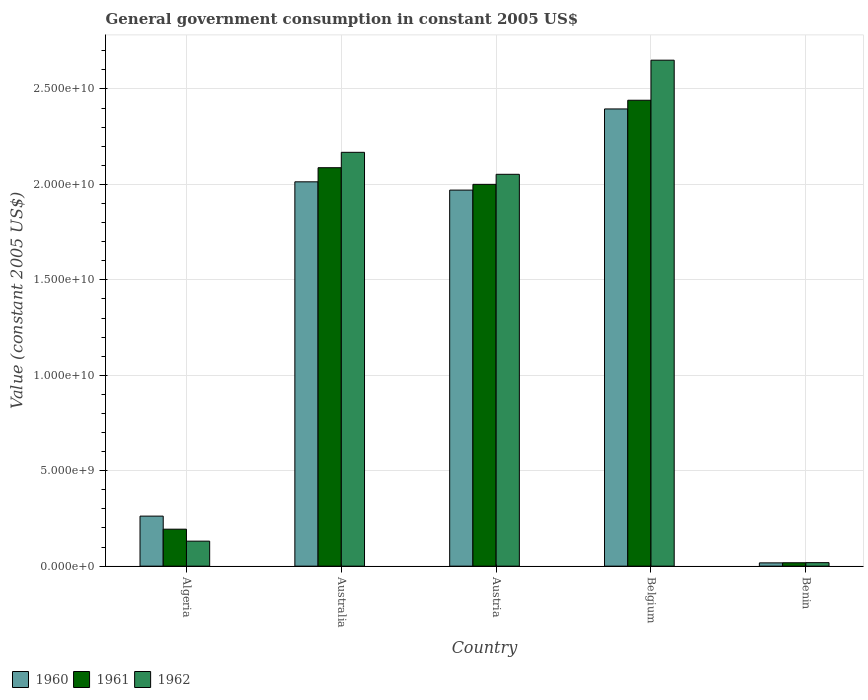How many bars are there on the 1st tick from the left?
Provide a succinct answer. 3. How many bars are there on the 2nd tick from the right?
Ensure brevity in your answer.  3. What is the label of the 5th group of bars from the left?
Give a very brief answer. Benin. In how many cases, is the number of bars for a given country not equal to the number of legend labels?
Your answer should be very brief. 0. What is the government conusmption in 1960 in Benin?
Offer a very short reply. 1.73e+08. Across all countries, what is the maximum government conusmption in 1962?
Keep it short and to the point. 2.65e+1. Across all countries, what is the minimum government conusmption in 1960?
Provide a short and direct response. 1.73e+08. In which country was the government conusmption in 1962 maximum?
Give a very brief answer. Belgium. In which country was the government conusmption in 1961 minimum?
Ensure brevity in your answer.  Benin. What is the total government conusmption in 1962 in the graph?
Ensure brevity in your answer.  7.02e+1. What is the difference between the government conusmption in 1961 in Algeria and that in Benin?
Provide a succinct answer. 1.76e+09. What is the difference between the government conusmption in 1962 in Belgium and the government conusmption in 1960 in Austria?
Make the answer very short. 6.81e+09. What is the average government conusmption in 1960 per country?
Provide a succinct answer. 1.33e+1. What is the difference between the government conusmption of/in 1961 and government conusmption of/in 1962 in Austria?
Your answer should be very brief. -5.26e+08. What is the ratio of the government conusmption in 1962 in Australia to that in Austria?
Make the answer very short. 1.06. What is the difference between the highest and the second highest government conusmption in 1961?
Keep it short and to the point. -8.72e+08. What is the difference between the highest and the lowest government conusmption in 1961?
Give a very brief answer. 2.42e+1. Are all the bars in the graph horizontal?
Give a very brief answer. No. How are the legend labels stacked?
Offer a very short reply. Horizontal. What is the title of the graph?
Offer a terse response. General government consumption in constant 2005 US$. What is the label or title of the X-axis?
Your response must be concise. Country. What is the label or title of the Y-axis?
Your answer should be very brief. Value (constant 2005 US$). What is the Value (constant 2005 US$) in 1960 in Algeria?
Your response must be concise. 2.62e+09. What is the Value (constant 2005 US$) in 1961 in Algeria?
Give a very brief answer. 1.94e+09. What is the Value (constant 2005 US$) in 1962 in Algeria?
Your answer should be very brief. 1.31e+09. What is the Value (constant 2005 US$) of 1960 in Australia?
Provide a short and direct response. 2.01e+1. What is the Value (constant 2005 US$) of 1961 in Australia?
Keep it short and to the point. 2.09e+1. What is the Value (constant 2005 US$) in 1962 in Australia?
Make the answer very short. 2.17e+1. What is the Value (constant 2005 US$) of 1960 in Austria?
Ensure brevity in your answer.  1.97e+1. What is the Value (constant 2005 US$) in 1961 in Austria?
Keep it short and to the point. 2.00e+1. What is the Value (constant 2005 US$) in 1962 in Austria?
Keep it short and to the point. 2.05e+1. What is the Value (constant 2005 US$) in 1960 in Belgium?
Give a very brief answer. 2.40e+1. What is the Value (constant 2005 US$) of 1961 in Belgium?
Keep it short and to the point. 2.44e+1. What is the Value (constant 2005 US$) of 1962 in Belgium?
Offer a terse response. 2.65e+1. What is the Value (constant 2005 US$) of 1960 in Benin?
Ensure brevity in your answer.  1.73e+08. What is the Value (constant 2005 US$) of 1961 in Benin?
Your answer should be very brief. 1.79e+08. What is the Value (constant 2005 US$) of 1962 in Benin?
Your answer should be compact. 1.85e+08. Across all countries, what is the maximum Value (constant 2005 US$) in 1960?
Your answer should be very brief. 2.40e+1. Across all countries, what is the maximum Value (constant 2005 US$) of 1961?
Your answer should be very brief. 2.44e+1. Across all countries, what is the maximum Value (constant 2005 US$) of 1962?
Offer a very short reply. 2.65e+1. Across all countries, what is the minimum Value (constant 2005 US$) in 1960?
Provide a succinct answer. 1.73e+08. Across all countries, what is the minimum Value (constant 2005 US$) of 1961?
Offer a terse response. 1.79e+08. Across all countries, what is the minimum Value (constant 2005 US$) in 1962?
Your answer should be very brief. 1.85e+08. What is the total Value (constant 2005 US$) of 1960 in the graph?
Your response must be concise. 6.66e+1. What is the total Value (constant 2005 US$) of 1961 in the graph?
Your answer should be compact. 6.74e+1. What is the total Value (constant 2005 US$) of 1962 in the graph?
Offer a very short reply. 7.02e+1. What is the difference between the Value (constant 2005 US$) of 1960 in Algeria and that in Australia?
Provide a short and direct response. -1.75e+1. What is the difference between the Value (constant 2005 US$) in 1961 in Algeria and that in Australia?
Ensure brevity in your answer.  -1.89e+1. What is the difference between the Value (constant 2005 US$) of 1962 in Algeria and that in Australia?
Keep it short and to the point. -2.04e+1. What is the difference between the Value (constant 2005 US$) of 1960 in Algeria and that in Austria?
Offer a terse response. -1.71e+1. What is the difference between the Value (constant 2005 US$) of 1961 in Algeria and that in Austria?
Offer a very short reply. -1.81e+1. What is the difference between the Value (constant 2005 US$) of 1962 in Algeria and that in Austria?
Your response must be concise. -1.92e+1. What is the difference between the Value (constant 2005 US$) in 1960 in Algeria and that in Belgium?
Keep it short and to the point. -2.13e+1. What is the difference between the Value (constant 2005 US$) of 1961 in Algeria and that in Belgium?
Ensure brevity in your answer.  -2.25e+1. What is the difference between the Value (constant 2005 US$) in 1962 in Algeria and that in Belgium?
Provide a succinct answer. -2.52e+1. What is the difference between the Value (constant 2005 US$) in 1960 in Algeria and that in Benin?
Give a very brief answer. 2.45e+09. What is the difference between the Value (constant 2005 US$) of 1961 in Algeria and that in Benin?
Offer a very short reply. 1.76e+09. What is the difference between the Value (constant 2005 US$) of 1962 in Algeria and that in Benin?
Make the answer very short. 1.13e+09. What is the difference between the Value (constant 2005 US$) of 1960 in Australia and that in Austria?
Provide a short and direct response. 4.34e+08. What is the difference between the Value (constant 2005 US$) of 1961 in Australia and that in Austria?
Ensure brevity in your answer.  8.72e+08. What is the difference between the Value (constant 2005 US$) of 1962 in Australia and that in Austria?
Your answer should be compact. 1.15e+09. What is the difference between the Value (constant 2005 US$) of 1960 in Australia and that in Belgium?
Ensure brevity in your answer.  -3.82e+09. What is the difference between the Value (constant 2005 US$) of 1961 in Australia and that in Belgium?
Offer a terse response. -3.53e+09. What is the difference between the Value (constant 2005 US$) of 1962 in Australia and that in Belgium?
Offer a terse response. -4.83e+09. What is the difference between the Value (constant 2005 US$) of 1960 in Australia and that in Benin?
Provide a short and direct response. 2.00e+1. What is the difference between the Value (constant 2005 US$) of 1961 in Australia and that in Benin?
Keep it short and to the point. 2.07e+1. What is the difference between the Value (constant 2005 US$) of 1962 in Australia and that in Benin?
Offer a terse response. 2.15e+1. What is the difference between the Value (constant 2005 US$) of 1960 in Austria and that in Belgium?
Provide a succinct answer. -4.25e+09. What is the difference between the Value (constant 2005 US$) in 1961 in Austria and that in Belgium?
Offer a terse response. -4.41e+09. What is the difference between the Value (constant 2005 US$) of 1962 in Austria and that in Belgium?
Provide a short and direct response. -5.98e+09. What is the difference between the Value (constant 2005 US$) of 1960 in Austria and that in Benin?
Provide a short and direct response. 1.95e+1. What is the difference between the Value (constant 2005 US$) of 1961 in Austria and that in Benin?
Provide a succinct answer. 1.98e+1. What is the difference between the Value (constant 2005 US$) of 1962 in Austria and that in Benin?
Your answer should be very brief. 2.03e+1. What is the difference between the Value (constant 2005 US$) of 1960 in Belgium and that in Benin?
Provide a succinct answer. 2.38e+1. What is the difference between the Value (constant 2005 US$) of 1961 in Belgium and that in Benin?
Your answer should be very brief. 2.42e+1. What is the difference between the Value (constant 2005 US$) in 1962 in Belgium and that in Benin?
Ensure brevity in your answer.  2.63e+1. What is the difference between the Value (constant 2005 US$) of 1960 in Algeria and the Value (constant 2005 US$) of 1961 in Australia?
Keep it short and to the point. -1.83e+1. What is the difference between the Value (constant 2005 US$) in 1960 in Algeria and the Value (constant 2005 US$) in 1962 in Australia?
Your answer should be very brief. -1.91e+1. What is the difference between the Value (constant 2005 US$) of 1961 in Algeria and the Value (constant 2005 US$) of 1962 in Australia?
Keep it short and to the point. -1.97e+1. What is the difference between the Value (constant 2005 US$) of 1960 in Algeria and the Value (constant 2005 US$) of 1961 in Austria?
Offer a terse response. -1.74e+1. What is the difference between the Value (constant 2005 US$) in 1960 in Algeria and the Value (constant 2005 US$) in 1962 in Austria?
Keep it short and to the point. -1.79e+1. What is the difference between the Value (constant 2005 US$) of 1961 in Algeria and the Value (constant 2005 US$) of 1962 in Austria?
Your response must be concise. -1.86e+1. What is the difference between the Value (constant 2005 US$) in 1960 in Algeria and the Value (constant 2005 US$) in 1961 in Belgium?
Offer a very short reply. -2.18e+1. What is the difference between the Value (constant 2005 US$) of 1960 in Algeria and the Value (constant 2005 US$) of 1962 in Belgium?
Ensure brevity in your answer.  -2.39e+1. What is the difference between the Value (constant 2005 US$) in 1961 in Algeria and the Value (constant 2005 US$) in 1962 in Belgium?
Provide a succinct answer. -2.46e+1. What is the difference between the Value (constant 2005 US$) in 1960 in Algeria and the Value (constant 2005 US$) in 1961 in Benin?
Give a very brief answer. 2.44e+09. What is the difference between the Value (constant 2005 US$) in 1960 in Algeria and the Value (constant 2005 US$) in 1962 in Benin?
Your answer should be compact. 2.44e+09. What is the difference between the Value (constant 2005 US$) of 1961 in Algeria and the Value (constant 2005 US$) of 1962 in Benin?
Ensure brevity in your answer.  1.75e+09. What is the difference between the Value (constant 2005 US$) in 1960 in Australia and the Value (constant 2005 US$) in 1961 in Austria?
Give a very brief answer. 1.33e+08. What is the difference between the Value (constant 2005 US$) in 1960 in Australia and the Value (constant 2005 US$) in 1962 in Austria?
Provide a succinct answer. -3.94e+08. What is the difference between the Value (constant 2005 US$) in 1961 in Australia and the Value (constant 2005 US$) in 1962 in Austria?
Offer a very short reply. 3.45e+08. What is the difference between the Value (constant 2005 US$) of 1960 in Australia and the Value (constant 2005 US$) of 1961 in Belgium?
Give a very brief answer. -4.27e+09. What is the difference between the Value (constant 2005 US$) in 1960 in Australia and the Value (constant 2005 US$) in 1962 in Belgium?
Keep it short and to the point. -6.37e+09. What is the difference between the Value (constant 2005 US$) in 1961 in Australia and the Value (constant 2005 US$) in 1962 in Belgium?
Give a very brief answer. -5.63e+09. What is the difference between the Value (constant 2005 US$) in 1960 in Australia and the Value (constant 2005 US$) in 1961 in Benin?
Your answer should be very brief. 2.00e+1. What is the difference between the Value (constant 2005 US$) of 1960 in Australia and the Value (constant 2005 US$) of 1962 in Benin?
Keep it short and to the point. 2.00e+1. What is the difference between the Value (constant 2005 US$) of 1961 in Australia and the Value (constant 2005 US$) of 1962 in Benin?
Offer a very short reply. 2.07e+1. What is the difference between the Value (constant 2005 US$) of 1960 in Austria and the Value (constant 2005 US$) of 1961 in Belgium?
Your answer should be very brief. -4.71e+09. What is the difference between the Value (constant 2005 US$) in 1960 in Austria and the Value (constant 2005 US$) in 1962 in Belgium?
Your response must be concise. -6.81e+09. What is the difference between the Value (constant 2005 US$) of 1961 in Austria and the Value (constant 2005 US$) of 1962 in Belgium?
Provide a short and direct response. -6.51e+09. What is the difference between the Value (constant 2005 US$) in 1960 in Austria and the Value (constant 2005 US$) in 1961 in Benin?
Offer a terse response. 1.95e+1. What is the difference between the Value (constant 2005 US$) in 1960 in Austria and the Value (constant 2005 US$) in 1962 in Benin?
Offer a very short reply. 1.95e+1. What is the difference between the Value (constant 2005 US$) of 1961 in Austria and the Value (constant 2005 US$) of 1962 in Benin?
Keep it short and to the point. 1.98e+1. What is the difference between the Value (constant 2005 US$) in 1960 in Belgium and the Value (constant 2005 US$) in 1961 in Benin?
Ensure brevity in your answer.  2.38e+1. What is the difference between the Value (constant 2005 US$) in 1960 in Belgium and the Value (constant 2005 US$) in 1962 in Benin?
Your answer should be very brief. 2.38e+1. What is the difference between the Value (constant 2005 US$) in 1961 in Belgium and the Value (constant 2005 US$) in 1962 in Benin?
Give a very brief answer. 2.42e+1. What is the average Value (constant 2005 US$) of 1960 per country?
Offer a very short reply. 1.33e+1. What is the average Value (constant 2005 US$) of 1961 per country?
Make the answer very short. 1.35e+1. What is the average Value (constant 2005 US$) in 1962 per country?
Give a very brief answer. 1.40e+1. What is the difference between the Value (constant 2005 US$) in 1960 and Value (constant 2005 US$) in 1961 in Algeria?
Keep it short and to the point. 6.84e+08. What is the difference between the Value (constant 2005 US$) of 1960 and Value (constant 2005 US$) of 1962 in Algeria?
Ensure brevity in your answer.  1.31e+09. What is the difference between the Value (constant 2005 US$) of 1961 and Value (constant 2005 US$) of 1962 in Algeria?
Make the answer very short. 6.27e+08. What is the difference between the Value (constant 2005 US$) in 1960 and Value (constant 2005 US$) in 1961 in Australia?
Give a very brief answer. -7.39e+08. What is the difference between the Value (constant 2005 US$) in 1960 and Value (constant 2005 US$) in 1962 in Australia?
Provide a succinct answer. -1.55e+09. What is the difference between the Value (constant 2005 US$) of 1961 and Value (constant 2005 US$) of 1962 in Australia?
Provide a succinct answer. -8.07e+08. What is the difference between the Value (constant 2005 US$) of 1960 and Value (constant 2005 US$) of 1961 in Austria?
Keep it short and to the point. -3.01e+08. What is the difference between the Value (constant 2005 US$) in 1960 and Value (constant 2005 US$) in 1962 in Austria?
Provide a succinct answer. -8.27e+08. What is the difference between the Value (constant 2005 US$) of 1961 and Value (constant 2005 US$) of 1962 in Austria?
Offer a very short reply. -5.26e+08. What is the difference between the Value (constant 2005 US$) in 1960 and Value (constant 2005 US$) in 1961 in Belgium?
Your answer should be very brief. -4.56e+08. What is the difference between the Value (constant 2005 US$) in 1960 and Value (constant 2005 US$) in 1962 in Belgium?
Your answer should be very brief. -2.55e+09. What is the difference between the Value (constant 2005 US$) in 1961 and Value (constant 2005 US$) in 1962 in Belgium?
Your answer should be very brief. -2.10e+09. What is the difference between the Value (constant 2005 US$) in 1960 and Value (constant 2005 US$) in 1961 in Benin?
Provide a succinct answer. -5.64e+06. What is the difference between the Value (constant 2005 US$) of 1960 and Value (constant 2005 US$) of 1962 in Benin?
Your answer should be very brief. -1.13e+07. What is the difference between the Value (constant 2005 US$) of 1961 and Value (constant 2005 US$) of 1962 in Benin?
Your answer should be compact. -5.64e+06. What is the ratio of the Value (constant 2005 US$) of 1960 in Algeria to that in Australia?
Provide a short and direct response. 0.13. What is the ratio of the Value (constant 2005 US$) in 1961 in Algeria to that in Australia?
Make the answer very short. 0.09. What is the ratio of the Value (constant 2005 US$) in 1962 in Algeria to that in Australia?
Your answer should be very brief. 0.06. What is the ratio of the Value (constant 2005 US$) of 1960 in Algeria to that in Austria?
Ensure brevity in your answer.  0.13. What is the ratio of the Value (constant 2005 US$) in 1961 in Algeria to that in Austria?
Offer a very short reply. 0.1. What is the ratio of the Value (constant 2005 US$) in 1962 in Algeria to that in Austria?
Your answer should be very brief. 0.06. What is the ratio of the Value (constant 2005 US$) of 1960 in Algeria to that in Belgium?
Make the answer very short. 0.11. What is the ratio of the Value (constant 2005 US$) in 1961 in Algeria to that in Belgium?
Provide a short and direct response. 0.08. What is the ratio of the Value (constant 2005 US$) of 1962 in Algeria to that in Belgium?
Make the answer very short. 0.05. What is the ratio of the Value (constant 2005 US$) in 1960 in Algeria to that in Benin?
Keep it short and to the point. 15.13. What is the ratio of the Value (constant 2005 US$) in 1961 in Algeria to that in Benin?
Your answer should be compact. 10.83. What is the ratio of the Value (constant 2005 US$) of 1962 in Algeria to that in Benin?
Your answer should be very brief. 7.1. What is the ratio of the Value (constant 2005 US$) in 1960 in Australia to that in Austria?
Provide a succinct answer. 1.02. What is the ratio of the Value (constant 2005 US$) of 1961 in Australia to that in Austria?
Your answer should be very brief. 1.04. What is the ratio of the Value (constant 2005 US$) of 1962 in Australia to that in Austria?
Your answer should be compact. 1.06. What is the ratio of the Value (constant 2005 US$) in 1960 in Australia to that in Belgium?
Provide a succinct answer. 0.84. What is the ratio of the Value (constant 2005 US$) of 1961 in Australia to that in Belgium?
Ensure brevity in your answer.  0.86. What is the ratio of the Value (constant 2005 US$) in 1962 in Australia to that in Belgium?
Provide a succinct answer. 0.82. What is the ratio of the Value (constant 2005 US$) in 1960 in Australia to that in Benin?
Provide a short and direct response. 116.16. What is the ratio of the Value (constant 2005 US$) in 1961 in Australia to that in Benin?
Give a very brief answer. 116.63. What is the ratio of the Value (constant 2005 US$) in 1962 in Australia to that in Benin?
Keep it short and to the point. 117.44. What is the ratio of the Value (constant 2005 US$) in 1960 in Austria to that in Belgium?
Your answer should be compact. 0.82. What is the ratio of the Value (constant 2005 US$) of 1961 in Austria to that in Belgium?
Your response must be concise. 0.82. What is the ratio of the Value (constant 2005 US$) in 1962 in Austria to that in Belgium?
Give a very brief answer. 0.77. What is the ratio of the Value (constant 2005 US$) of 1960 in Austria to that in Benin?
Your answer should be compact. 113.66. What is the ratio of the Value (constant 2005 US$) in 1961 in Austria to that in Benin?
Make the answer very short. 111.76. What is the ratio of the Value (constant 2005 US$) in 1962 in Austria to that in Benin?
Your answer should be very brief. 111.2. What is the ratio of the Value (constant 2005 US$) of 1960 in Belgium to that in Benin?
Offer a very short reply. 138.18. What is the ratio of the Value (constant 2005 US$) in 1961 in Belgium to that in Benin?
Your answer should be very brief. 136.38. What is the ratio of the Value (constant 2005 US$) of 1962 in Belgium to that in Benin?
Your answer should be very brief. 143.58. What is the difference between the highest and the second highest Value (constant 2005 US$) in 1960?
Offer a very short reply. 3.82e+09. What is the difference between the highest and the second highest Value (constant 2005 US$) of 1961?
Your answer should be very brief. 3.53e+09. What is the difference between the highest and the second highest Value (constant 2005 US$) in 1962?
Your answer should be very brief. 4.83e+09. What is the difference between the highest and the lowest Value (constant 2005 US$) in 1960?
Offer a terse response. 2.38e+1. What is the difference between the highest and the lowest Value (constant 2005 US$) of 1961?
Your answer should be very brief. 2.42e+1. What is the difference between the highest and the lowest Value (constant 2005 US$) in 1962?
Provide a succinct answer. 2.63e+1. 